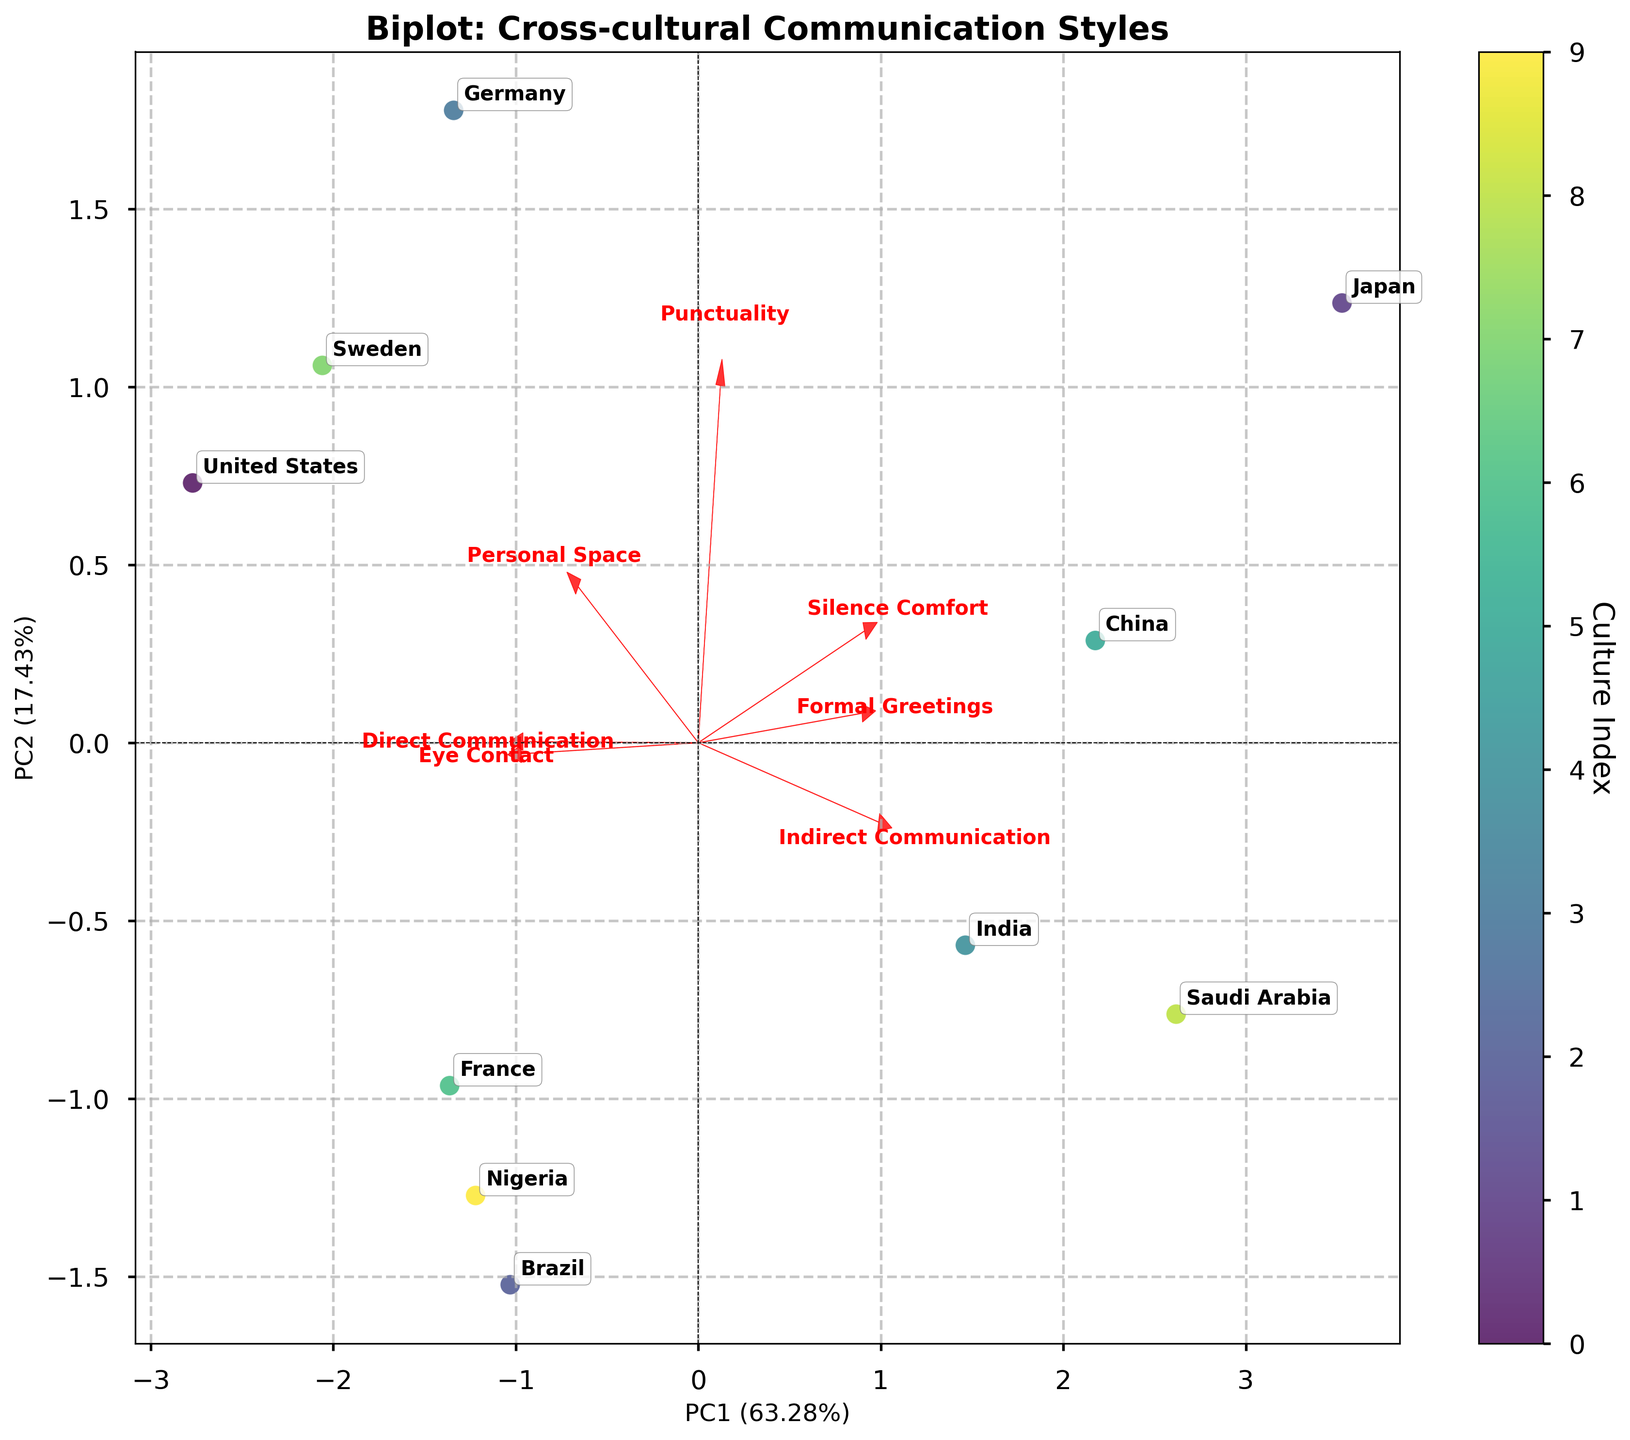What is the title of the figure? The title is typically located at the top of the plot and provides a general description of the content. In this case, the title describes what the plot represents about cross-cultural communication styles.
Answer: Biplot: Cross-cultural Communication Styles How many cultural groups are represented in the figure? Inspect the number of distinct labels or cultural names annotated on the plot. Each label represents a different cultural group.
Answer: 10 Which two cultures are positioned furthest apart in the figure? To determine the two cultures that are furthest apart, you need to look for the two points with the maximum distance between them on the plot.
Answer: United States and Japan Which communication style has the longest feature vector? The feature with the longest vector in a biplot is the one that has the longest red arrow from the origin. This indicates the strongest correlation with the principal components.
Answer: Formal Greetings Which culture has the highest value for Direct Communication? Identify the data point representing the culture that is marked closest to the direction of the 'Direct Communication' arrow. You should consider the length of this feature's vector to ensure accurate interpretation.
Answer: Germany Which cultures are closely grouped together in terms of their communication styles? Look for clusters of points in the plot that are spatially close to each other. These cultures will appear near one another and may have similar communication styles.
Answer: United States, Nigeria, and Brazil Is 'Eye Contact' more closely correlated with PC1 or PC2? The direction of the 'Eye Contact' vector relative to the x-axis (PC1) and y-axis (PC2) will indicate its closer correlation. The vector component contributing to either PC will show this.
Answer: PC1 How does 'Punctuality' vary among the different cultures? Identify the direction and length of the 'Punctuality' vector and then consider the cultures that lie in the opposite direction to see variations. The closer a culture's point is to the Punctuality vector, the higher its value for punctuality.
Answer: Germany and Japan score high in 'Punctuality.' Which feature vector is almost perpendicular to the 'Personal Space' vector? Look for the vector that forms a near 90-degree angle with the 'Personal Space' vector. Perpendicular vectors indicate a lack of correlation between the features they represent.
Answer: Silence Comfort Which culture has the lowest value for 'Eye Contact'? Identify the culture point that lies furthest in the opposite direction to where the 'Eye Contact' vector points. This culture would demonstrate the lowest propensity for eye contact.
Answer: Japan 